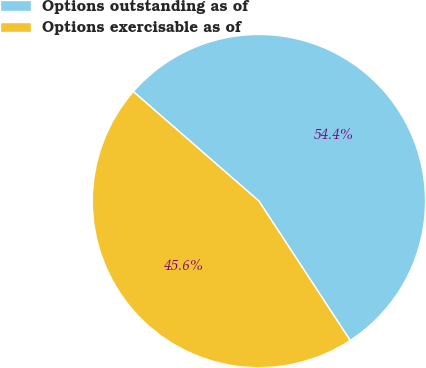<chart> <loc_0><loc_0><loc_500><loc_500><pie_chart><fcel>Options outstanding as of<fcel>Options exercisable as of<nl><fcel>54.36%<fcel>45.64%<nl></chart> 